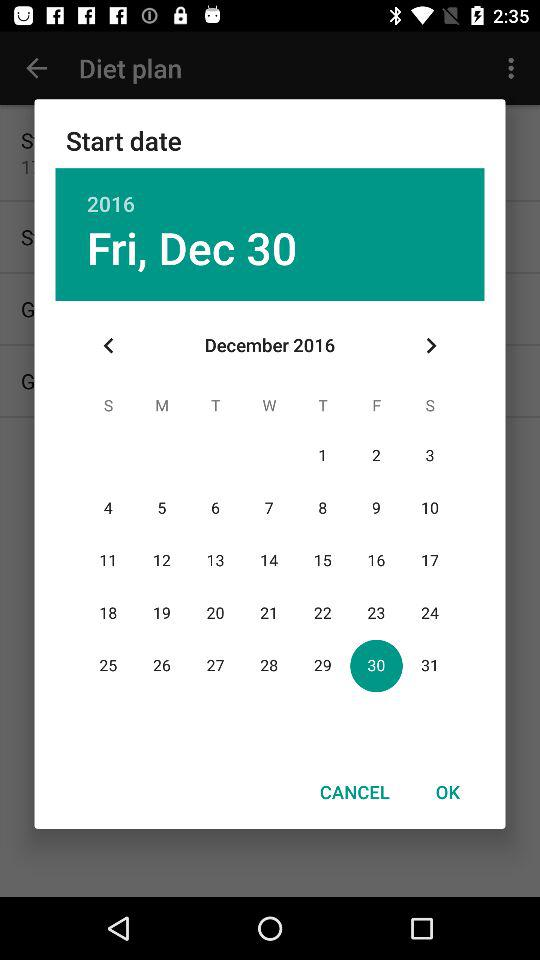Which holiday falls on Friday, December 10, 2016?
When the provided information is insufficient, respond with <no answer>. <no answer> 